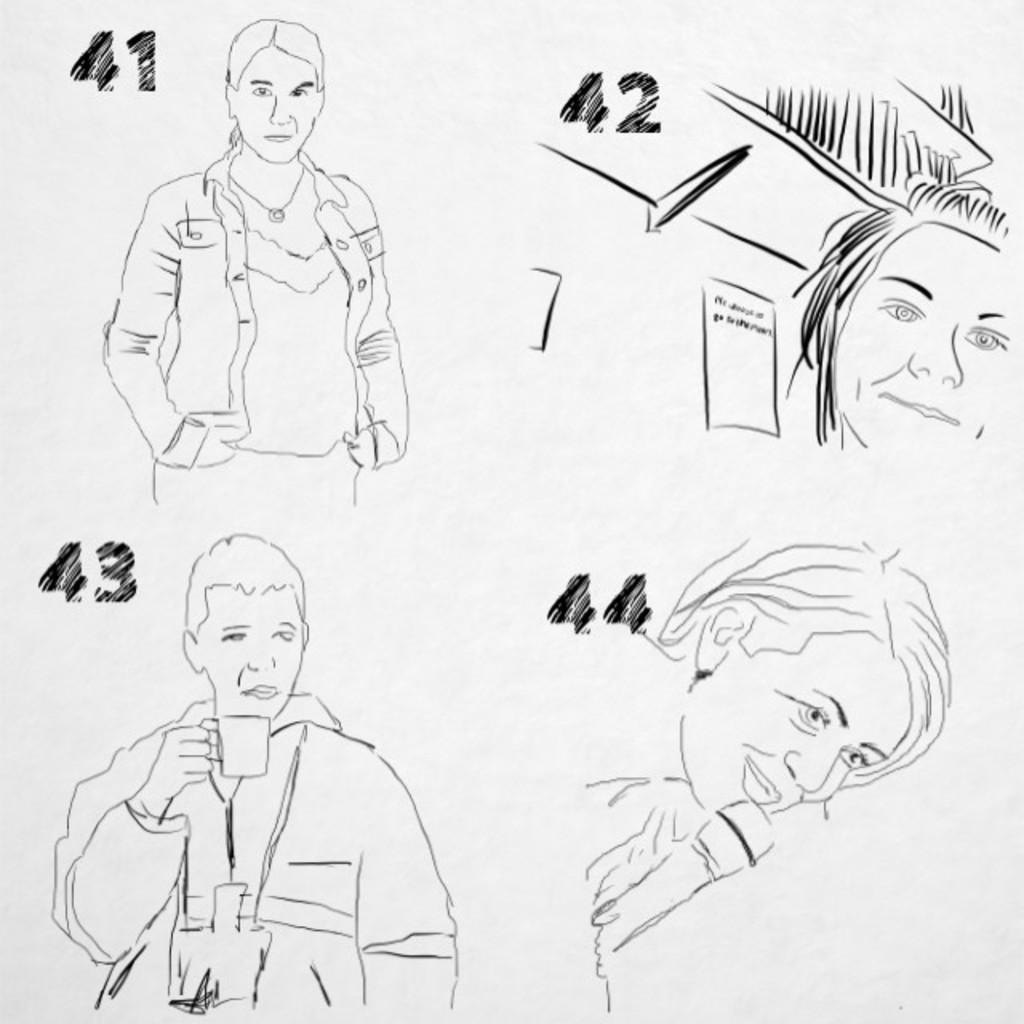How would you summarize this image in a sentence or two? In this image I can see a drawing , on which I can see persons images and a person holding a cup, numbers. 